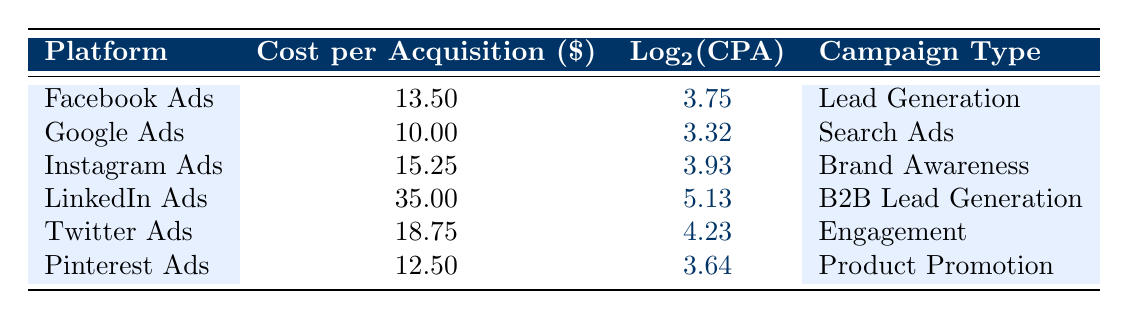What is the cost per acquisition for Google Ads? The table shows a specific entry for Google Ads, under the "Cost per Acquisition" column, which is listed as 10.00.
Answer: 10.00 Which platform has the highest cost per acquisition? By scanning through the "Cost per Acquisition" column, LinkedIn Ads has the highest value at 35.00.
Answer: LinkedIn Ads What is the logarithmic value of the cost per acquisition for Twitter Ads? The value of "Log2(CPA)" for Twitter Ads is directly stated in the table as 4.23.
Answer: 4.23 What is the average cost per acquisition across all platforms? First, sum all the cost values: 13.50 + 10.00 + 15.25 + 35.00 + 18.75 + 12.50 = 105.00; then divide by the number of platforms (6): 105.00 / 6 = 17.50.
Answer: 17.50 True or False: Instagram Ads has a higher cost per acquisition than Pinterest Ads. By checking the "Cost per Acquisition" values, Instagram Ads (15.25) is indeed higher than Pinterest Ads (12.50), so the statement is true.
Answer: True What is the difference in cost per acquisition between the cheapest and the most expensive platform? The cheapest platform is Google Ads with 10.00 and the most expensive is LinkedIn Ads with 35.00. The difference is calculated as 35.00 - 10.00 = 25.00.
Answer: 25.00 True or False: All platforms have a cost per acquisition greater than 10.00. By reviewing the cost values, Pinterest Ads has a cost per acquisition of 12.50, which is greater than 10.00, but all platforms listed do have costs over this amount. Therefore, the statement is true.
Answer: True Which campaign type has the highest cost per acquisition and what is that value? Identifying the highest value in the "Cost per Acquisition" column shows that LinkedIn Ads, with a campaign type of B2B Lead Generation, has the highest cost at 35.00.
Answer: B2B Lead Generation, 35.00 What is the total cost per acquisition for the Lead Generation campaign type? The "Lead Generation" campaign appears only once for Facebook Ads at 13.50. Therefore, total cost per acquisition for this type is 13.50.
Answer: 13.50 